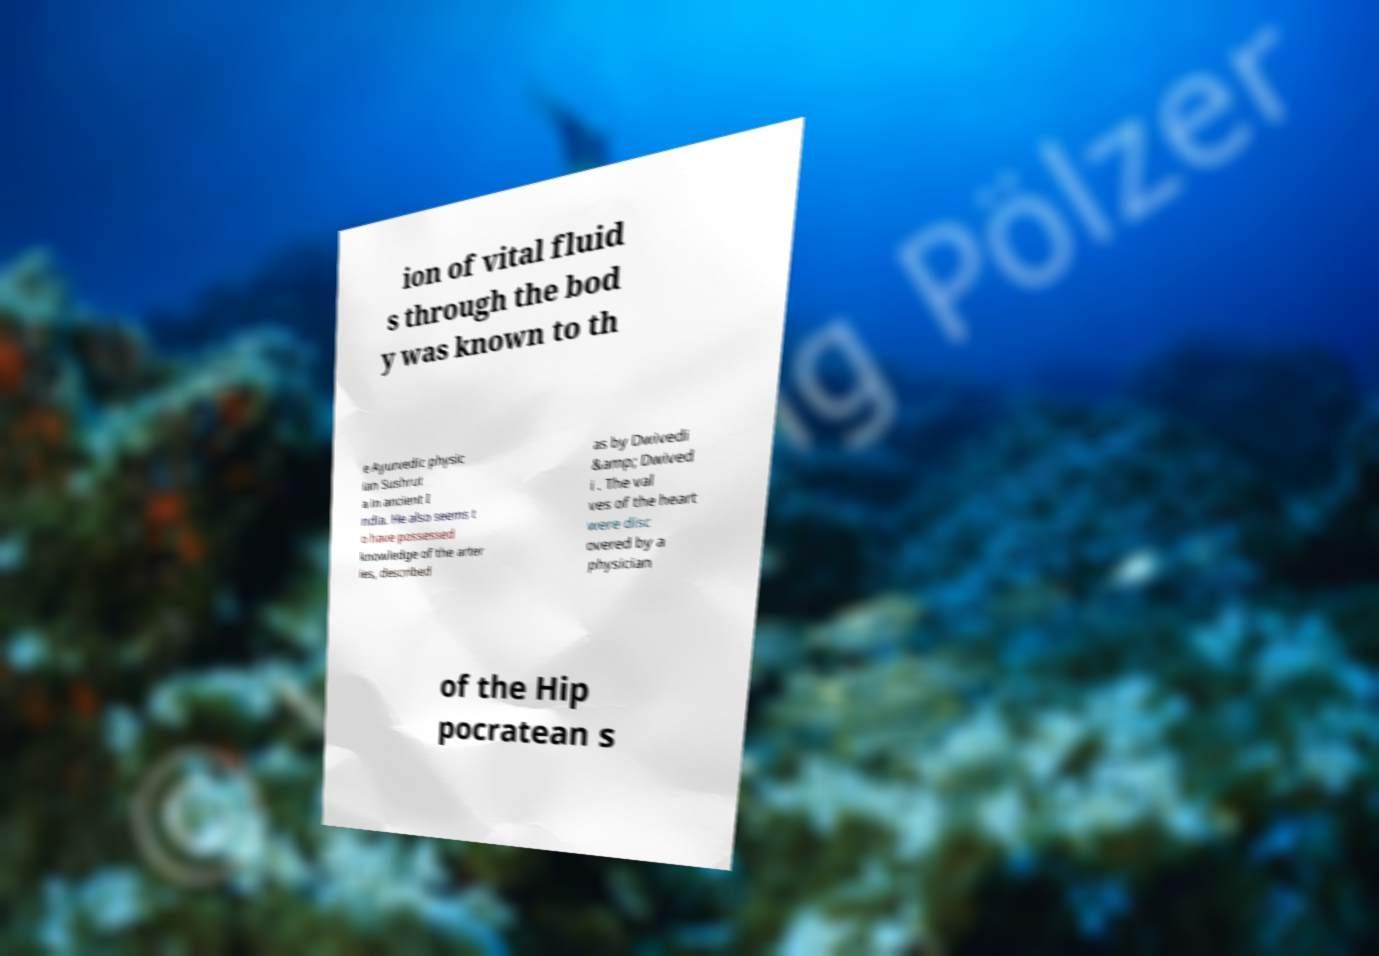For documentation purposes, I need the text within this image transcribed. Could you provide that? ion of vital fluid s through the bod y was known to th e Ayurvedic physic ian Sushrut a in ancient I ndia. He also seems t o have possessed knowledge of the arter ies, described as by Dwivedi &amp; Dwived i . The val ves of the heart were disc overed by a physician of the Hip pocratean s 